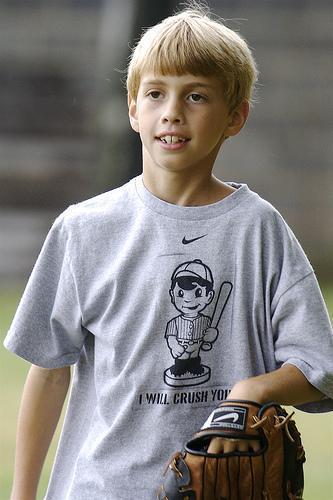How many people are in this photo?
Give a very brief answer. 1. 